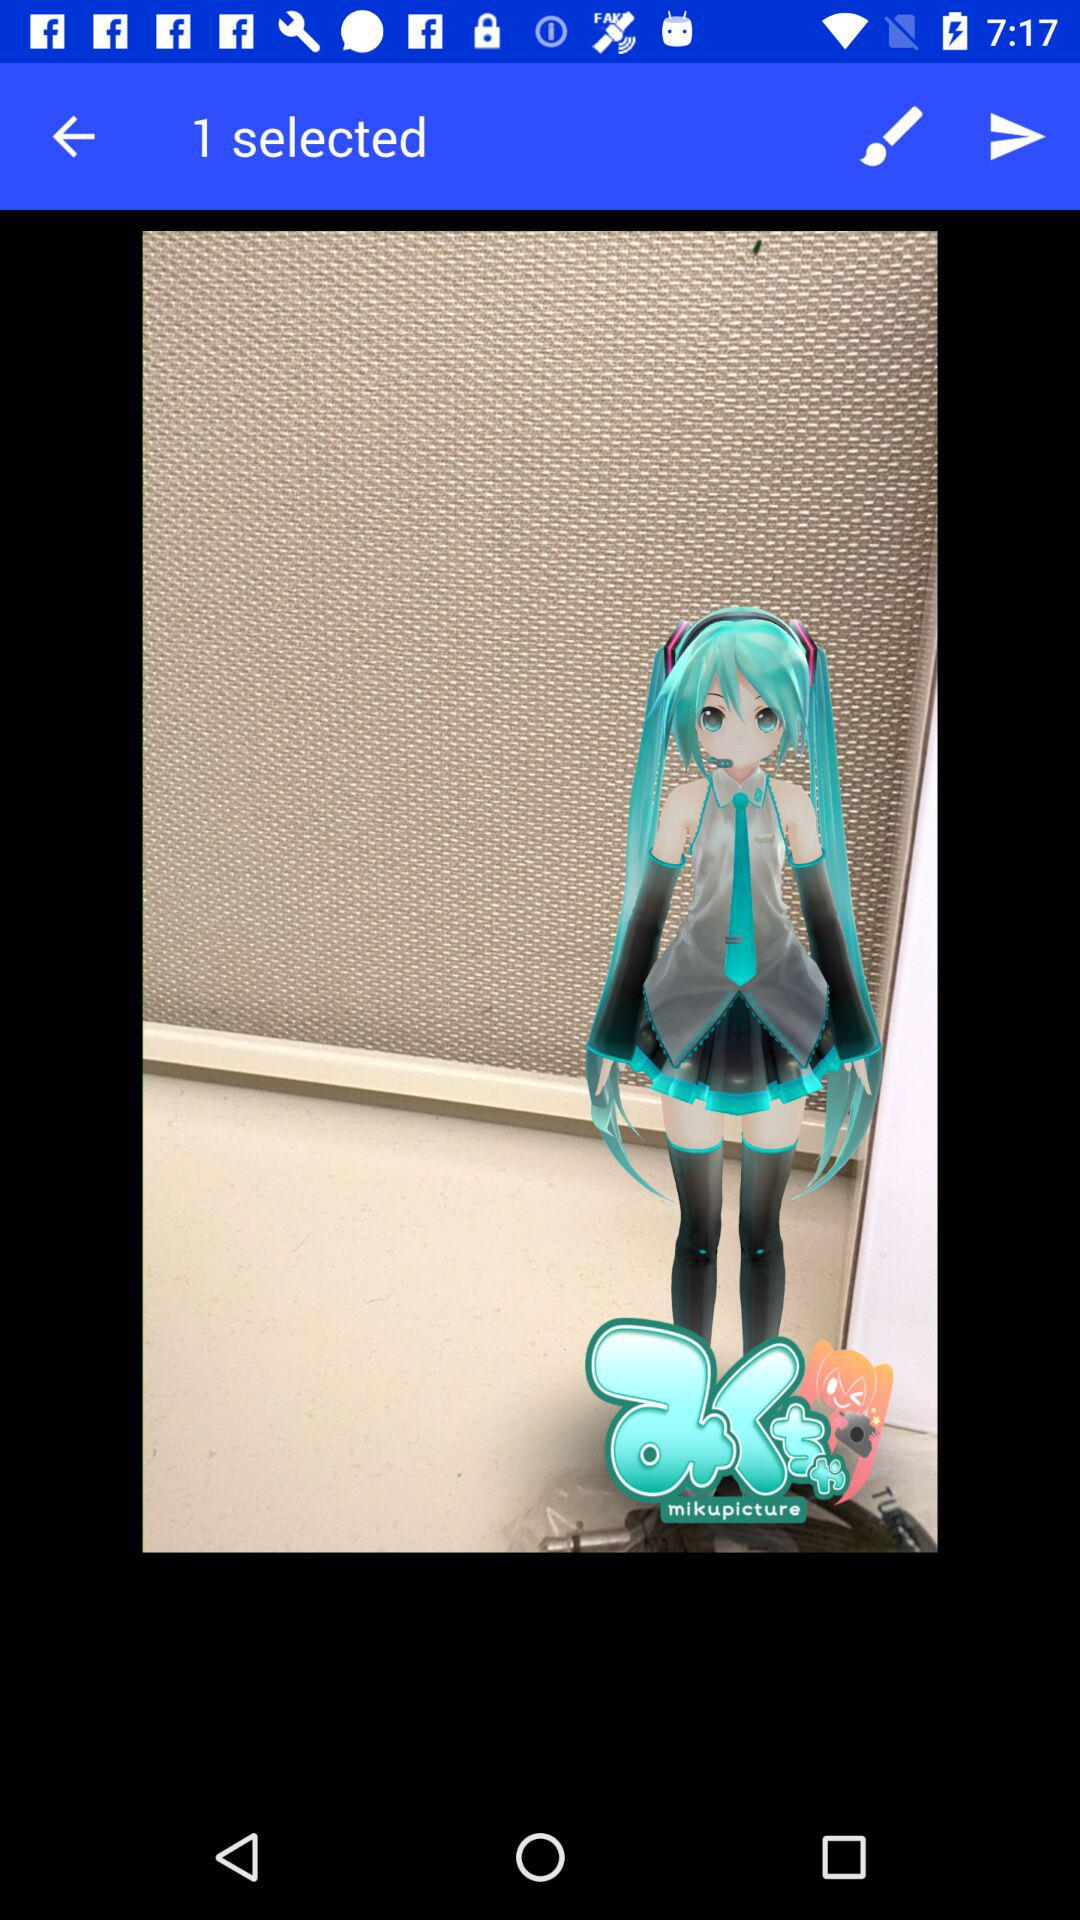How many images are selected? There is 1 selected image. 